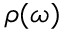<formula> <loc_0><loc_0><loc_500><loc_500>\rho ( \omega )</formula> 